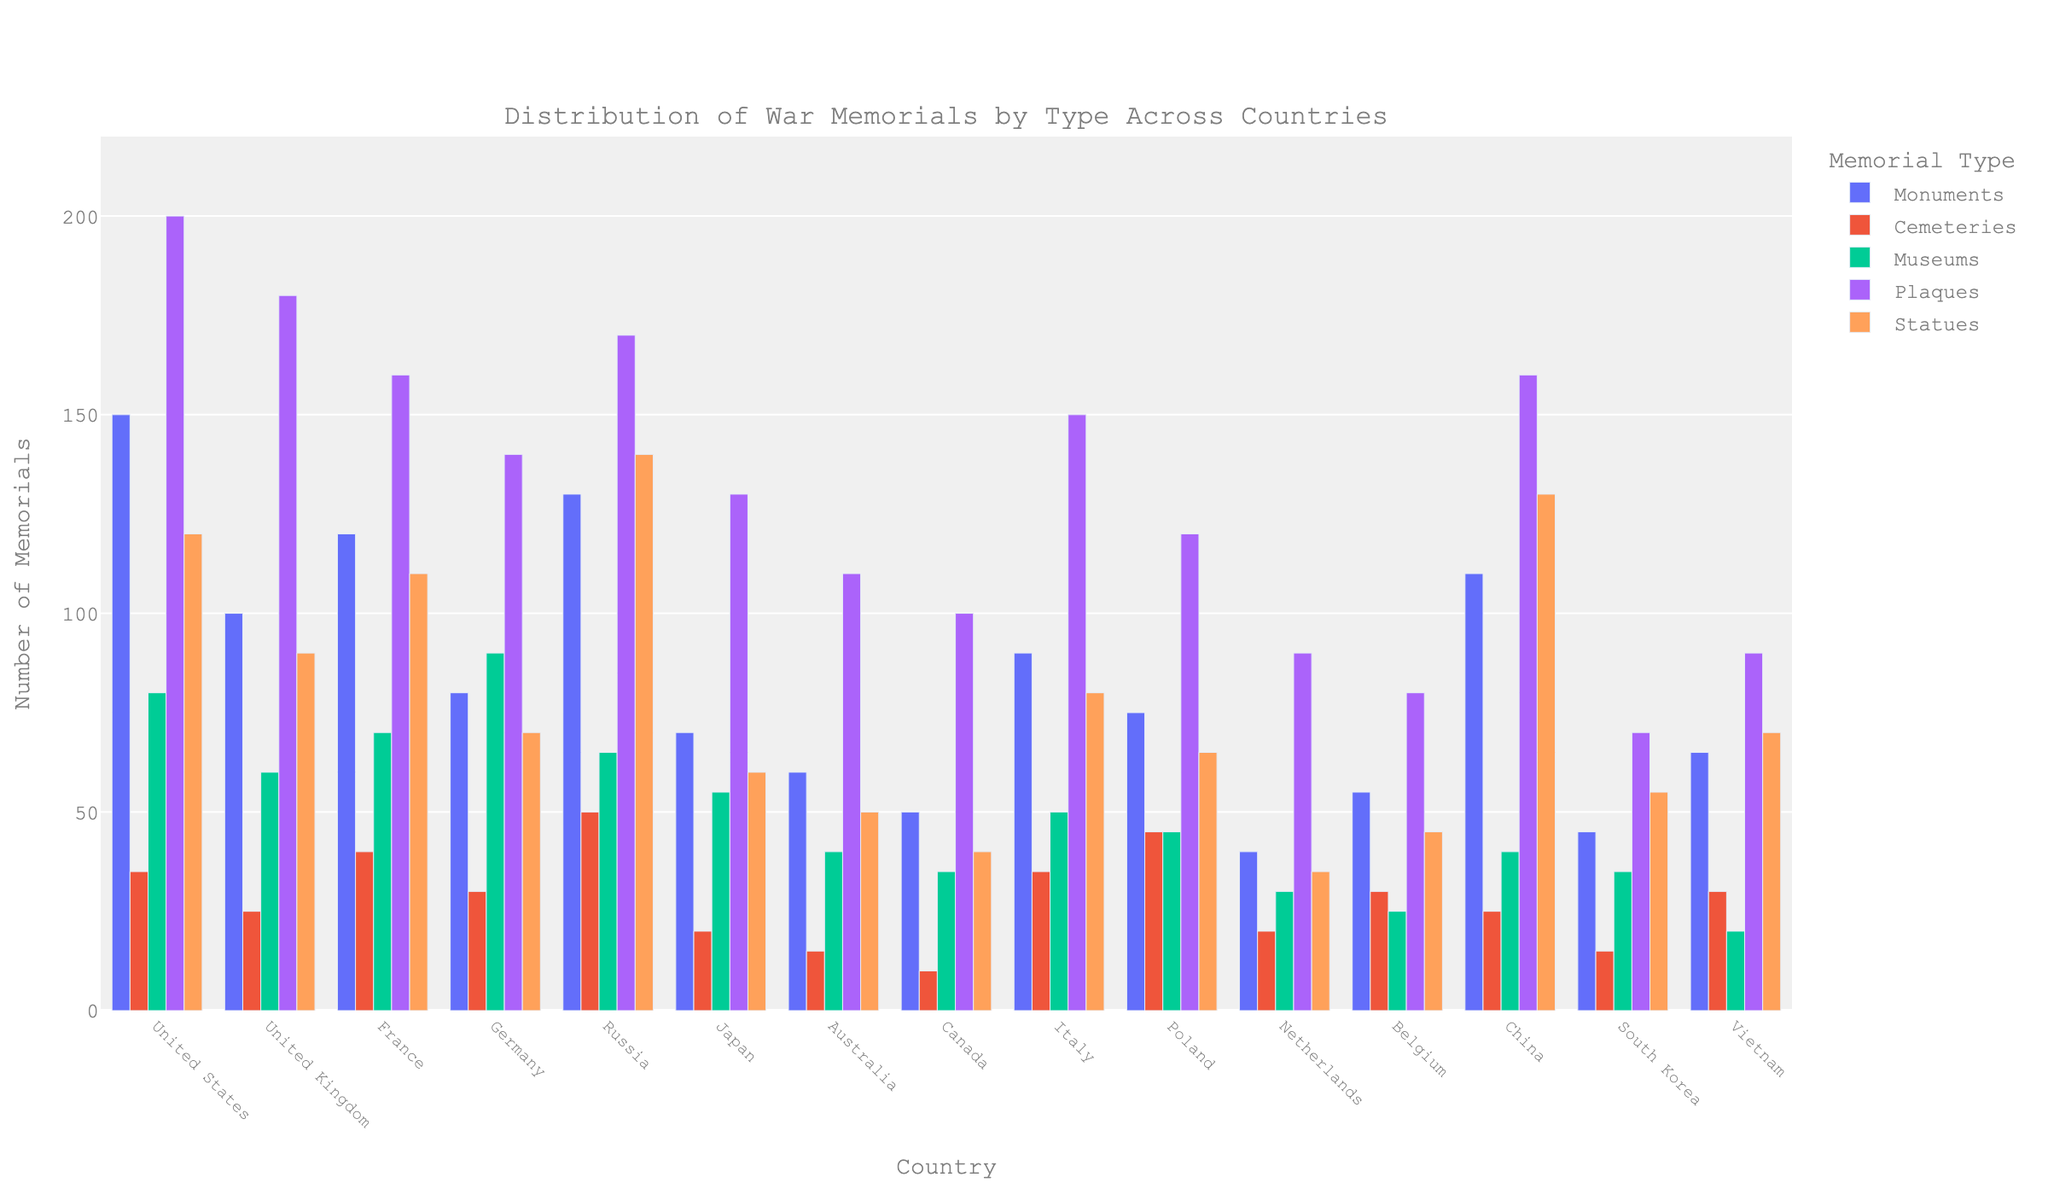Which country has the most plaques? The height of the bar representing plaques for each country shows that the United States has the tallest bar.
Answer: United States How many more monuments does the United States have compared to Germany? The bar for monuments shows 150 for the United States and 80 for Germany. So, 150 - 80 = 70.
Answer: 70 Which type of war memorial is the most common in Japan? By comparing the heights of the bars for Japan, it is clear that the bar for plaques is the highest.
Answer: Plaques How many total museums are present in France, Germany, and Italy combined? Summing the museum counts from France (70), Germany (90), and Italy (50), we get 70 + 90 + 50 = 210.
Answer: 210 Which country has the fewest statues? Looking at the bar heights for statues across all countries, Canada has the lowest bar.
Answer: Canada What is the average number of cemeteries in the United States and Russia? The United States has 35 cemeteries, and Russia has 50. The average is (35 + 50) / 2 = 42.5.
Answer: 42.5 Which memorial type has the greatest variance in the number of occurrences across countries? By visually comparing the variance in bar heights across types, plaques have highly varying heights, indicating higher variance.
Answer: Plaques Does France have more or fewer war memorials in total compared to Germany? Summing the different types for each country: France (120+40+70+160+110=500) and Germany (80+30+90+140+70=410). France has more.
Answer: More Which country has a higher number of museums, Japan or the Netherlands? The height of Japan's museum bar (55) is greater than the Netherlands' bar (30).
Answer: Japan What is the sum of monuments and cemeteries in China and Australia? Summing the monuments and cemeteries: China (110 + 25 = 135) and Australia (60 + 15 = 75), then adding these sums: 135 + 75 = 210.
Answer: 210 